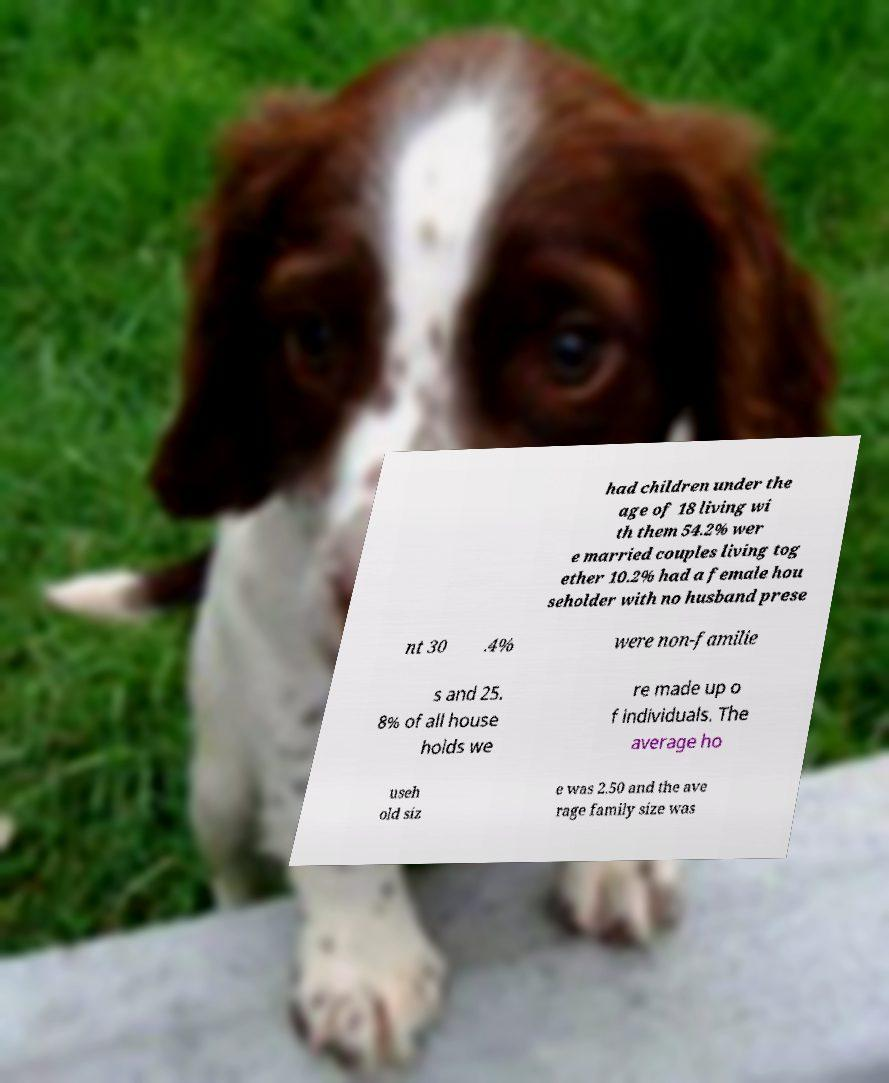What messages or text are displayed in this image? I need them in a readable, typed format. had children under the age of 18 living wi th them 54.2% wer e married couples living tog ether 10.2% had a female hou seholder with no husband prese nt 30 .4% were non-familie s and 25. 8% of all house holds we re made up o f individuals. The average ho useh old siz e was 2.50 and the ave rage family size was 